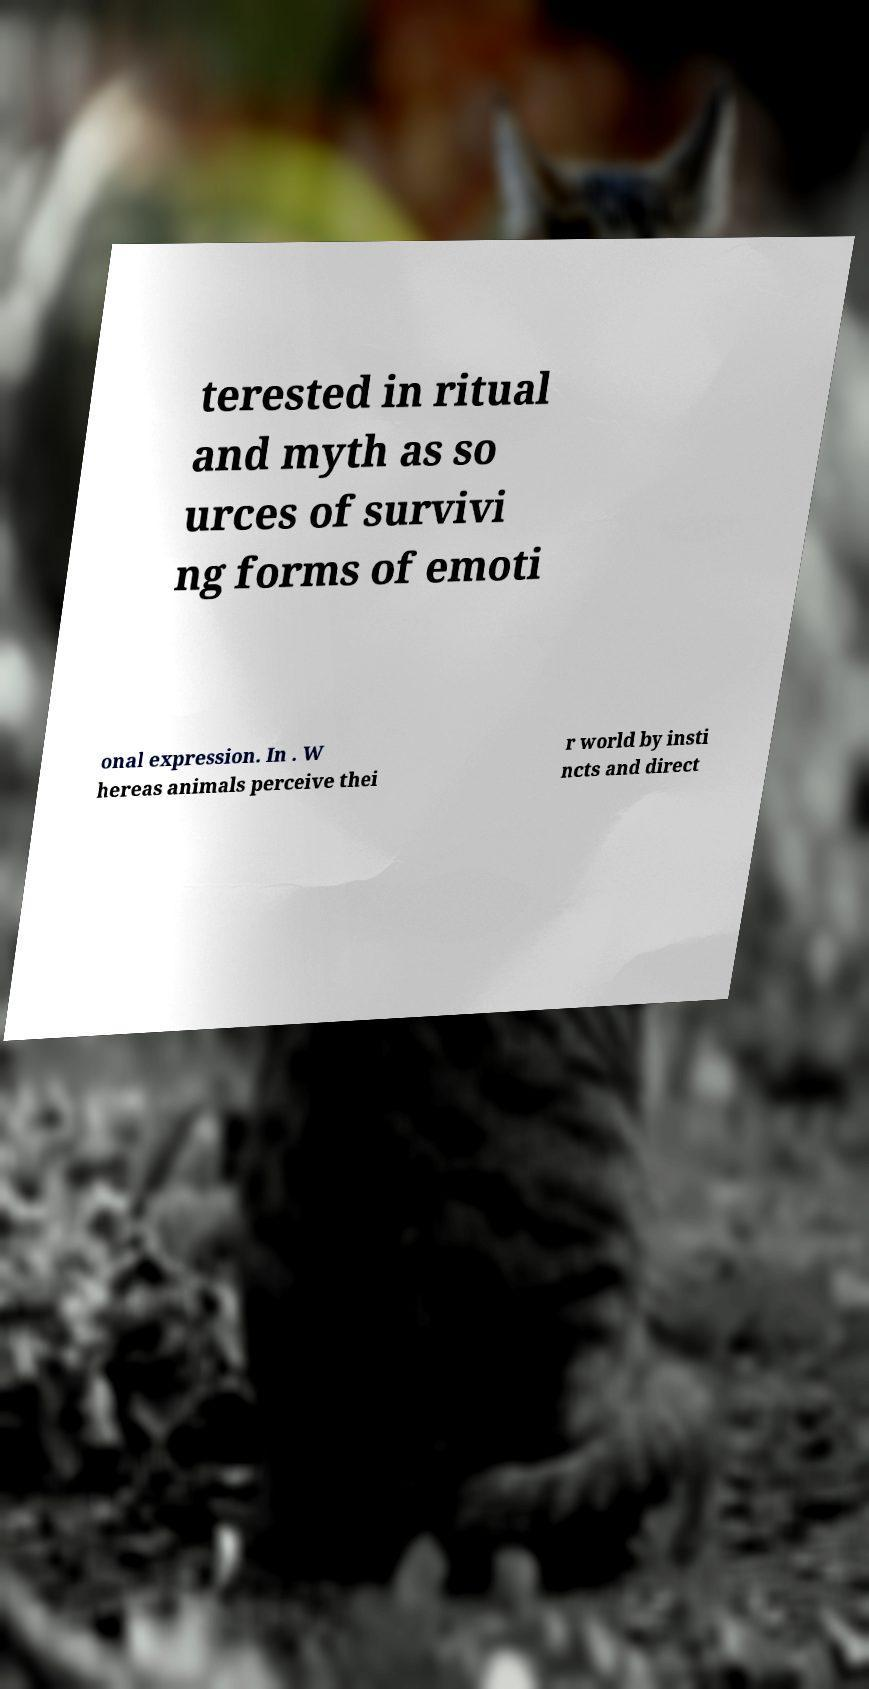For documentation purposes, I need the text within this image transcribed. Could you provide that? terested in ritual and myth as so urces of survivi ng forms of emoti onal expression. In . W hereas animals perceive thei r world by insti ncts and direct 